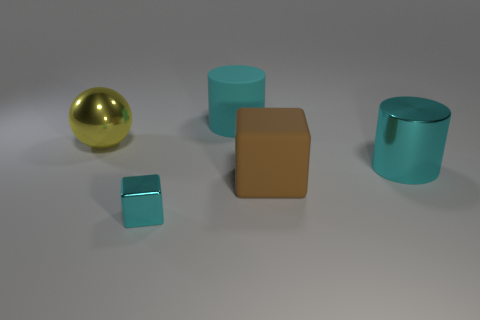Add 3 small cyan metallic objects. How many objects exist? 8 Subtract all cylinders. How many objects are left? 3 Add 5 large brown matte cubes. How many large brown matte cubes are left? 6 Add 1 large green metallic spheres. How many large green metallic spheres exist? 1 Subtract 0 green balls. How many objects are left? 5 Subtract all large metal cylinders. Subtract all cyan metallic cubes. How many objects are left? 3 